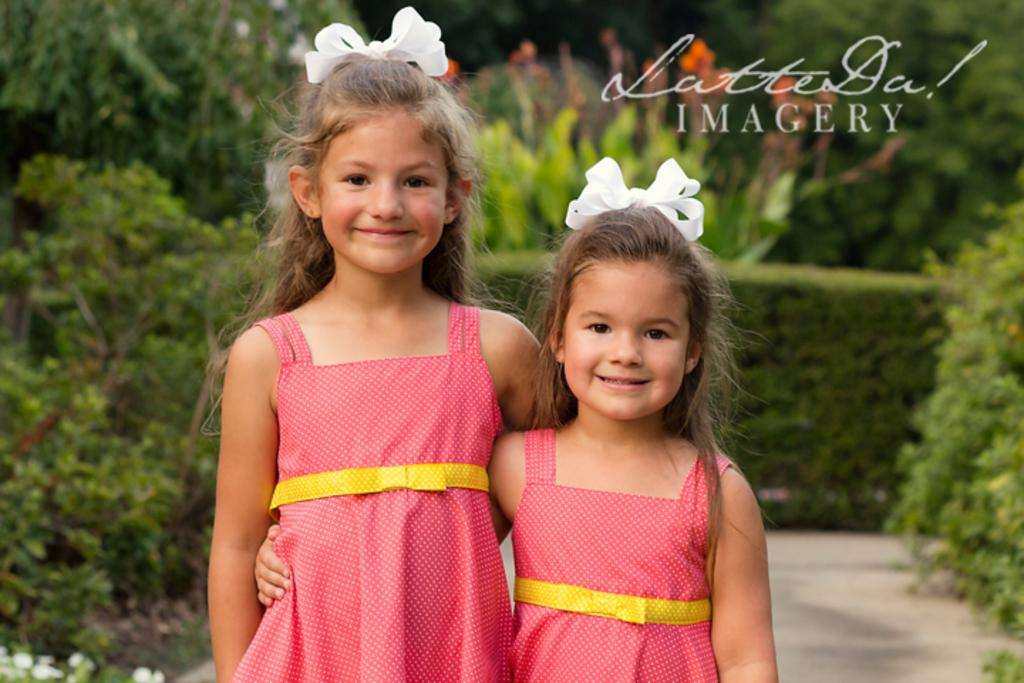How many people are in the image? There are two girls in the image. What are the girls doing in the image? Both girls are smiling. What can be seen on the girls' heads in the image? The girls are wearing white color ribbons. What is visible in the background of the image? There are trees in the background of the image. What type of action is the sink performing in the image? There is no sink present in the image. How many times do the girls fall in the image? The girls do not fall in the image; they are both smiling. 